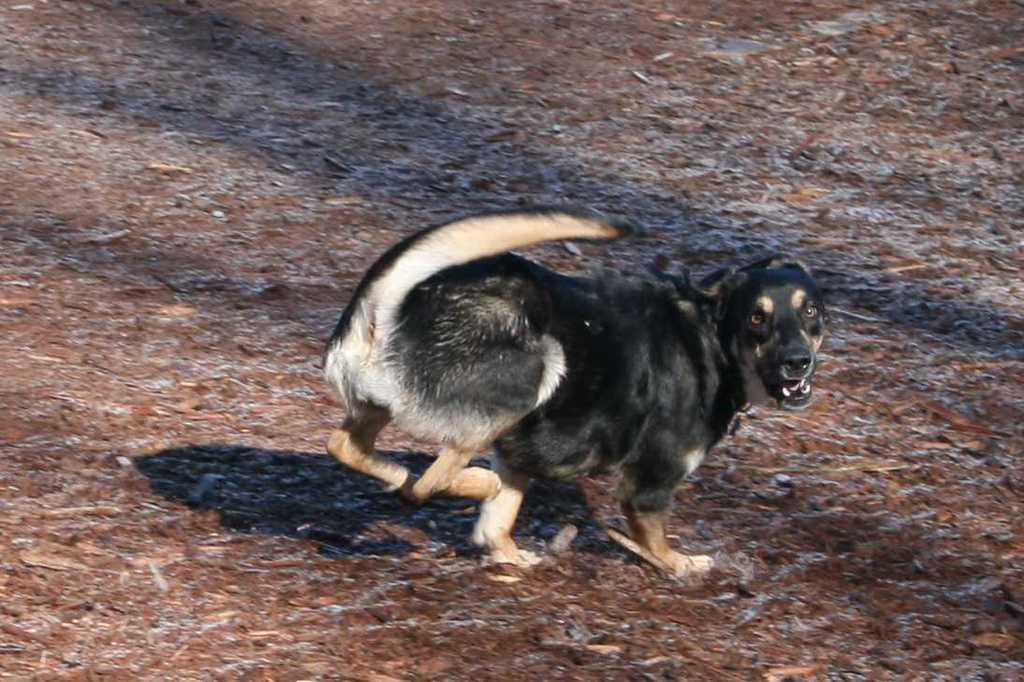What animal is present in the image? There is a dog in the image. Where is the dog located in the image? The dog is on the ground. What type of cheese is the dog eating in the image? There is no cheese present in the image; the dog is simply on the ground. 